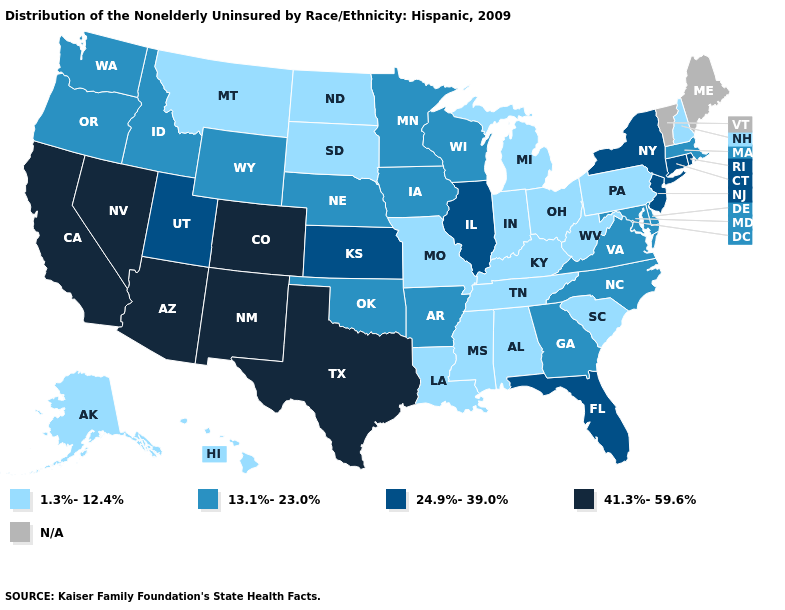Which states hav the highest value in the Northeast?
Give a very brief answer. Connecticut, New Jersey, New York, Rhode Island. Does Missouri have the highest value in the USA?
Answer briefly. No. Name the states that have a value in the range 24.9%-39.0%?
Be succinct. Connecticut, Florida, Illinois, Kansas, New Jersey, New York, Rhode Island, Utah. Is the legend a continuous bar?
Give a very brief answer. No. What is the highest value in states that border North Dakota?
Be succinct. 13.1%-23.0%. What is the highest value in the South ?
Write a very short answer. 41.3%-59.6%. Does Montana have the lowest value in the West?
Be succinct. Yes. Which states hav the highest value in the West?
Short answer required. Arizona, California, Colorado, Nevada, New Mexico. What is the value of Rhode Island?
Give a very brief answer. 24.9%-39.0%. What is the value of South Dakota?
Concise answer only. 1.3%-12.4%. Name the states that have a value in the range 13.1%-23.0%?
Short answer required. Arkansas, Delaware, Georgia, Idaho, Iowa, Maryland, Massachusetts, Minnesota, Nebraska, North Carolina, Oklahoma, Oregon, Virginia, Washington, Wisconsin, Wyoming. How many symbols are there in the legend?
Answer briefly. 5. What is the value of Montana?
Answer briefly. 1.3%-12.4%. Which states have the highest value in the USA?
Concise answer only. Arizona, California, Colorado, Nevada, New Mexico, Texas. 